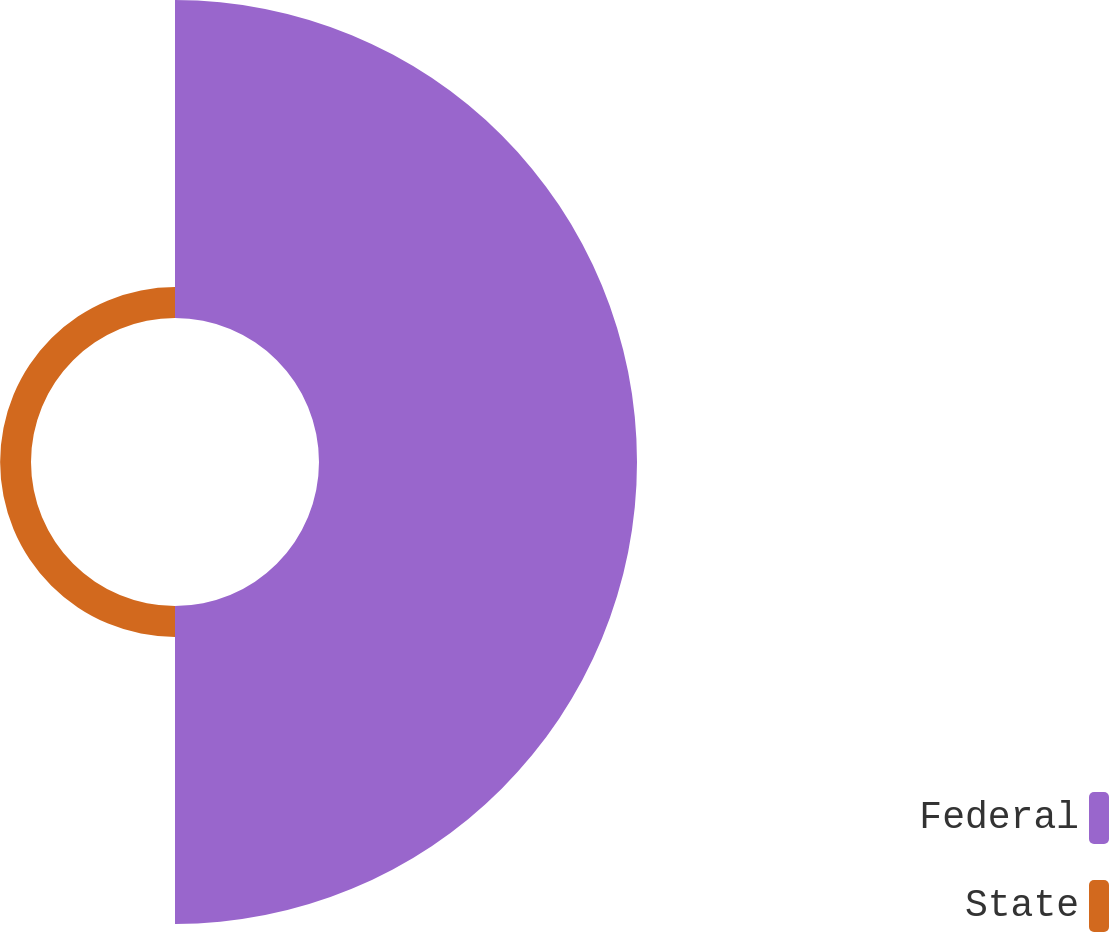Convert chart. <chart><loc_0><loc_0><loc_500><loc_500><pie_chart><fcel>Federal<fcel>State<nl><fcel>91.15%<fcel>8.85%<nl></chart> 